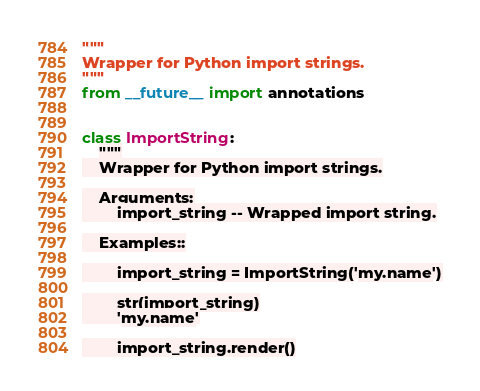Convert code to text. <code><loc_0><loc_0><loc_500><loc_500><_Python_>"""
Wrapper for Python import strings.
"""
from __future__ import annotations


class ImportString:
    """
    Wrapper for Python import strings.

    Arguments:
        import_string -- Wrapped import string.

    Examples::

        import_string = ImportString('my.name')

        str(import_string)
        'my.name'

        import_string.render()</code> 